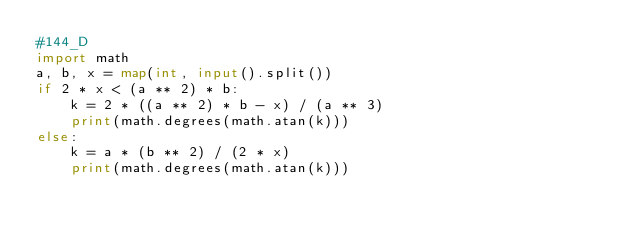Convert code to text. <code><loc_0><loc_0><loc_500><loc_500><_Python_>#144_D
import math
a, b, x = map(int, input().split())
if 2 * x < (a ** 2) * b:
    k = 2 * ((a ** 2) * b - x) / (a ** 3)
    print(math.degrees(math.atan(k)))
else:
    k = a * (b ** 2) / (2 * x)
    print(math.degrees(math.atan(k)))</code> 